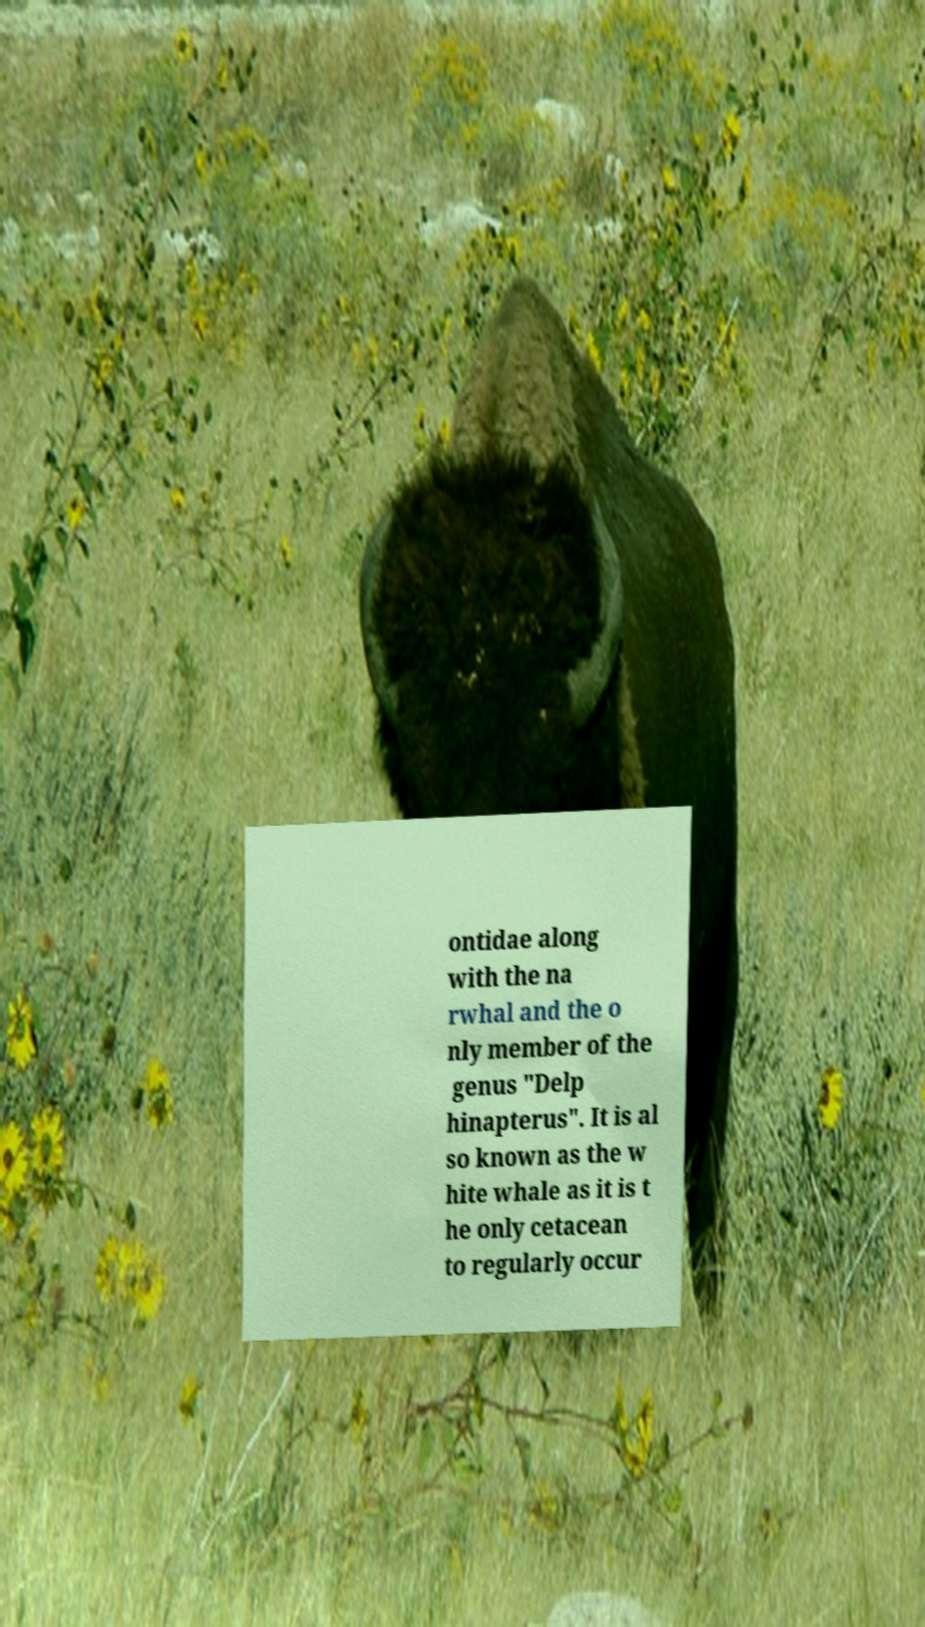Please identify and transcribe the text found in this image. ontidae along with the na rwhal and the o nly member of the genus "Delp hinapterus". It is al so known as the w hite whale as it is t he only cetacean to regularly occur 